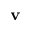<formula> <loc_0><loc_0><loc_500><loc_500>v</formula> 